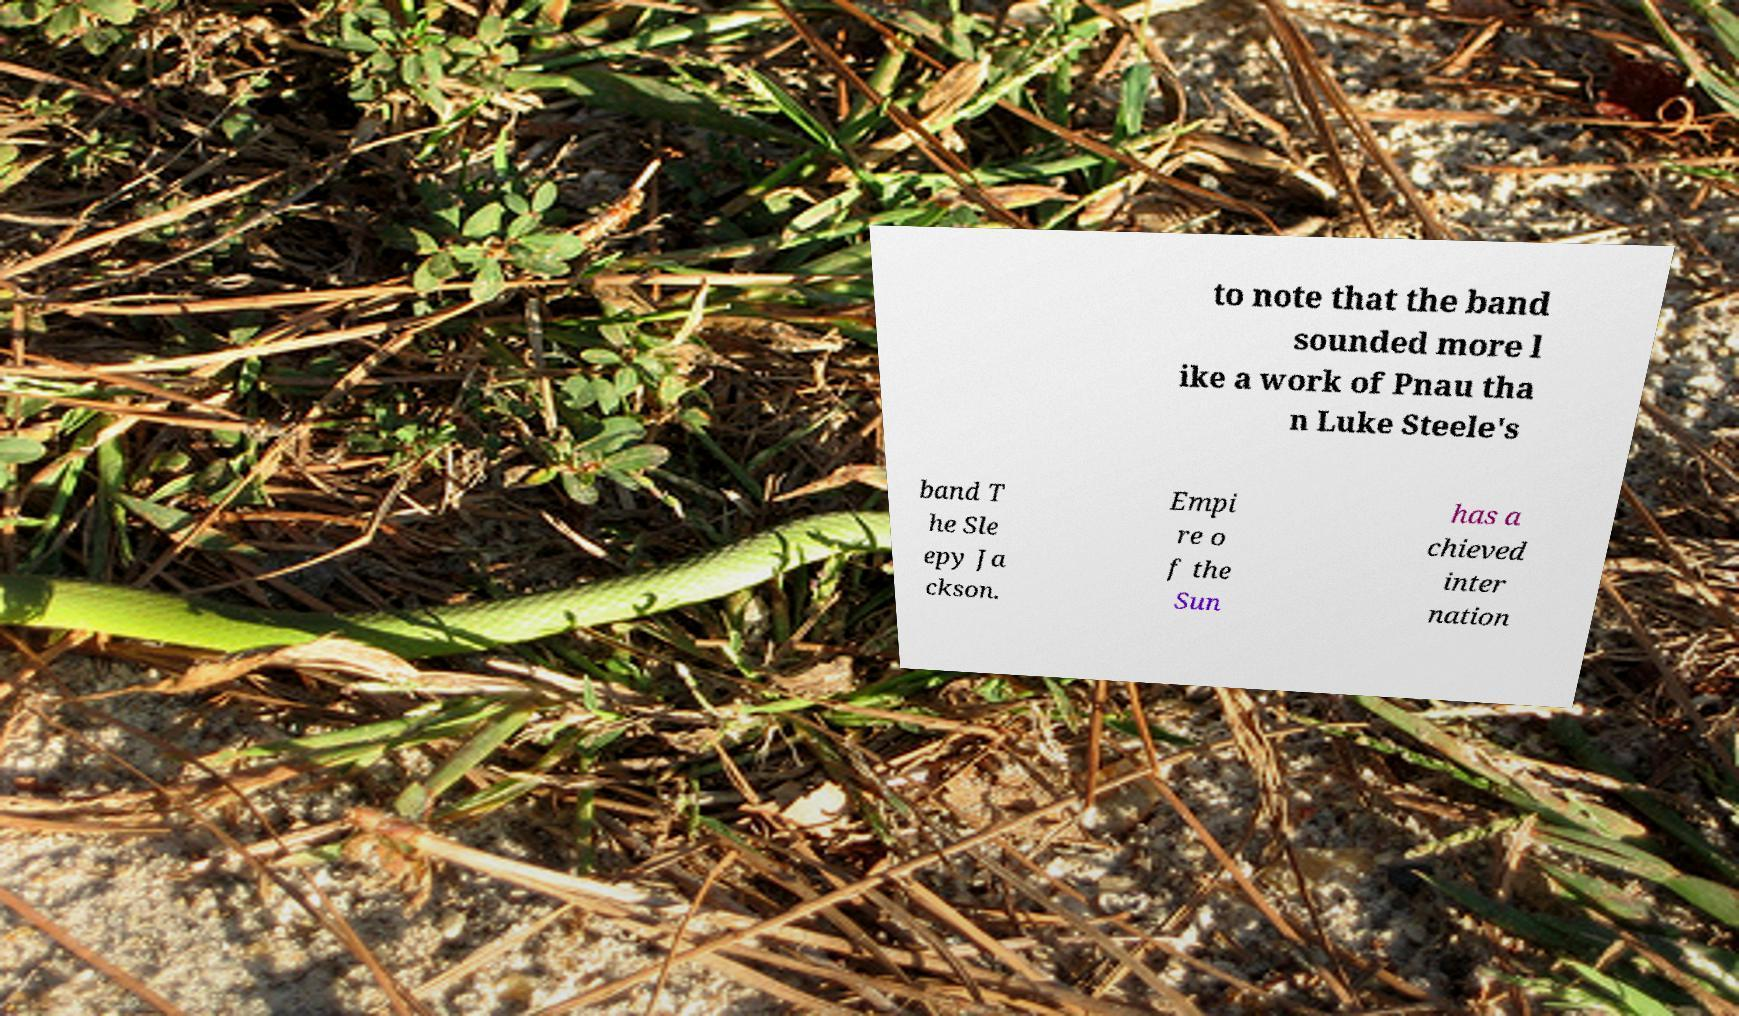What messages or text are displayed in this image? I need them in a readable, typed format. to note that the band sounded more l ike a work of Pnau tha n Luke Steele's band T he Sle epy Ja ckson. Empi re o f the Sun has a chieved inter nation 